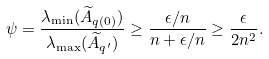<formula> <loc_0><loc_0><loc_500><loc_500>\psi & = \frac { \lambda _ { \min } ( \widetilde { A } _ { q ( 0 ) } ) } { \lambda _ { \max } ( \widetilde { A } _ { q ^ { \prime } } ) } \geq \frac { \epsilon / n } { n + \epsilon / n } \geq \frac { \epsilon } { 2 n ^ { 2 } } .</formula> 